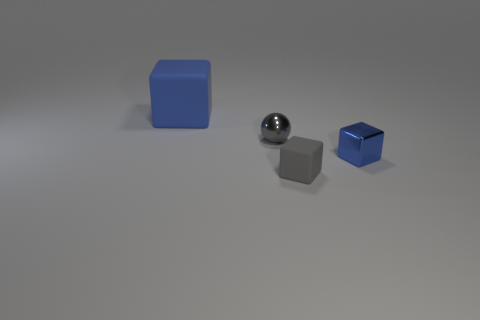What number of small things are cyan rubber cylinders or blue objects?
Your response must be concise. 1. There is a small thing that is the same color as the large rubber block; what is its material?
Your answer should be compact. Metal. Is there a large red cylinder made of the same material as the large blue block?
Your answer should be compact. No. There is a blue cube in front of the metallic ball; is it the same size as the large blue rubber cube?
Give a very brief answer. No. Is there a tiny gray matte cube that is to the right of the block behind the gray thing that is left of the tiny gray matte cube?
Your answer should be compact. Yes. What number of shiny things are either small cylinders or large cubes?
Your answer should be compact. 0. How many other objects are the same shape as the blue shiny object?
Give a very brief answer. 2. Are there more tiny blue metal blocks than red cubes?
Keep it short and to the point. Yes. How big is the rubber thing behind the matte thing in front of the large blue thing that is behind the small blue object?
Ensure brevity in your answer.  Large. There is a metallic object on the left side of the tiny blue shiny block; what size is it?
Your answer should be very brief. Small. 